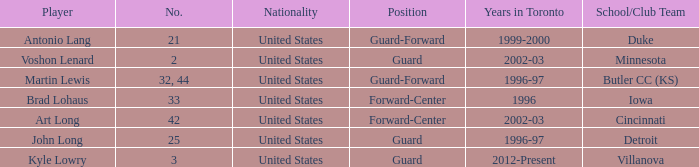What school did player number 21 play for? Duke. 